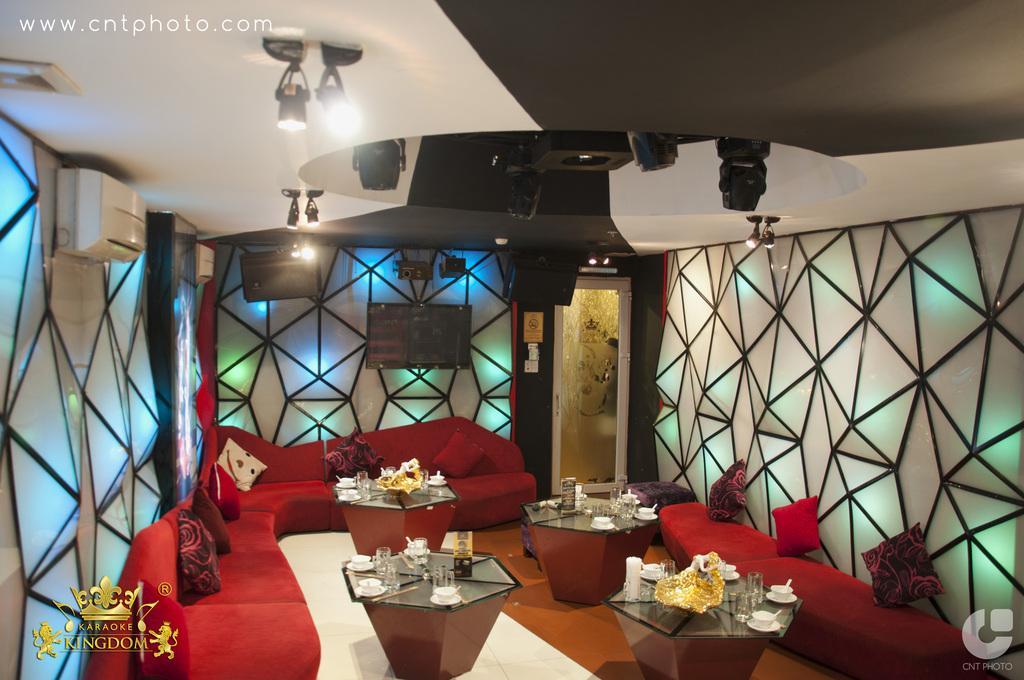How would you summarize this image in a sentence or two? This image is clicked inside the room where we can see there are tables in the middle. On the tables there are cups,glasses and tissue papers. Beside the table there are sofas on which there are pillows. At the top there are lights. In the middle there is a television which is attached to the wall. On the wall there is a design with the glass. On the left side top there is an air conditioner attached to the wall. 